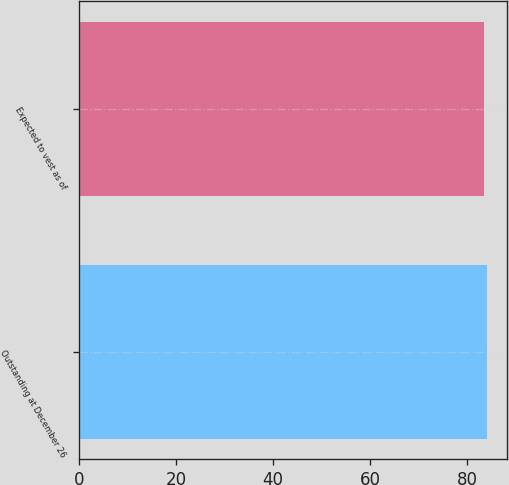<chart> <loc_0><loc_0><loc_500><loc_500><bar_chart><fcel>Outstanding at December 26<fcel>Expected to vest as of<nl><fcel>84.03<fcel>83.52<nl></chart> 